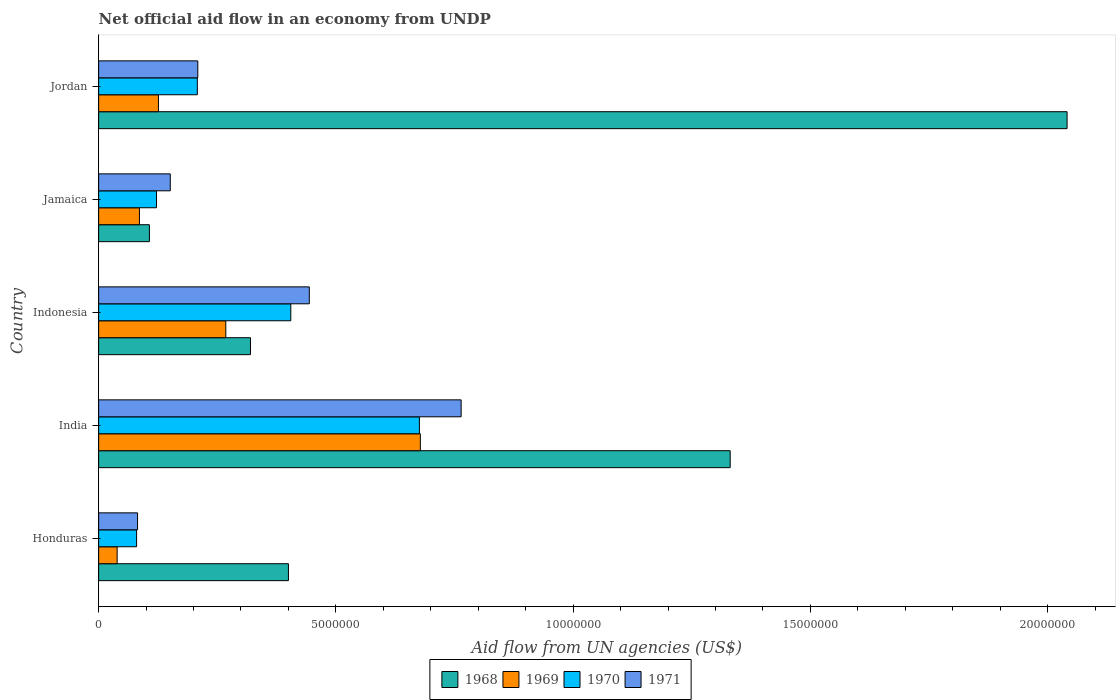How many different coloured bars are there?
Make the answer very short. 4. Are the number of bars per tick equal to the number of legend labels?
Make the answer very short. Yes. How many bars are there on the 3rd tick from the top?
Keep it short and to the point. 4. In how many cases, is the number of bars for a given country not equal to the number of legend labels?
Ensure brevity in your answer.  0. What is the net official aid flow in 1970 in India?
Provide a succinct answer. 6.76e+06. Across all countries, what is the maximum net official aid flow in 1969?
Offer a very short reply. 6.78e+06. Across all countries, what is the minimum net official aid flow in 1968?
Ensure brevity in your answer.  1.07e+06. In which country was the net official aid flow in 1968 maximum?
Provide a short and direct response. Jordan. In which country was the net official aid flow in 1968 minimum?
Offer a terse response. Jamaica. What is the total net official aid flow in 1969 in the graph?
Offer a terse response. 1.20e+07. What is the difference between the net official aid flow in 1968 in Honduras and that in Jordan?
Provide a short and direct response. -1.64e+07. What is the difference between the net official aid flow in 1971 in Jordan and the net official aid flow in 1969 in Indonesia?
Your response must be concise. -5.90e+05. What is the average net official aid flow in 1971 per country?
Your answer should be very brief. 3.30e+06. What is the ratio of the net official aid flow in 1970 in Honduras to that in India?
Provide a succinct answer. 0.12. What is the difference between the highest and the second highest net official aid flow in 1969?
Make the answer very short. 4.10e+06. What is the difference between the highest and the lowest net official aid flow in 1971?
Make the answer very short. 6.82e+06. In how many countries, is the net official aid flow in 1969 greater than the average net official aid flow in 1969 taken over all countries?
Ensure brevity in your answer.  2. Is the sum of the net official aid flow in 1971 in Honduras and Jordan greater than the maximum net official aid flow in 1969 across all countries?
Keep it short and to the point. No. What does the 3rd bar from the top in Jordan represents?
Your response must be concise. 1969. What does the 1st bar from the bottom in India represents?
Keep it short and to the point. 1968. Is it the case that in every country, the sum of the net official aid flow in 1971 and net official aid flow in 1968 is greater than the net official aid flow in 1969?
Your answer should be very brief. Yes. How many bars are there?
Offer a terse response. 20. How many countries are there in the graph?
Offer a terse response. 5. Where does the legend appear in the graph?
Offer a very short reply. Bottom center. How many legend labels are there?
Your answer should be compact. 4. What is the title of the graph?
Your answer should be very brief. Net official aid flow in an economy from UNDP. Does "2008" appear as one of the legend labels in the graph?
Your answer should be very brief. No. What is the label or title of the X-axis?
Provide a succinct answer. Aid flow from UN agencies (US$). What is the label or title of the Y-axis?
Provide a short and direct response. Country. What is the Aid flow from UN agencies (US$) in 1968 in Honduras?
Make the answer very short. 4.00e+06. What is the Aid flow from UN agencies (US$) of 1970 in Honduras?
Ensure brevity in your answer.  8.00e+05. What is the Aid flow from UN agencies (US$) of 1971 in Honduras?
Offer a terse response. 8.20e+05. What is the Aid flow from UN agencies (US$) in 1968 in India?
Give a very brief answer. 1.33e+07. What is the Aid flow from UN agencies (US$) in 1969 in India?
Ensure brevity in your answer.  6.78e+06. What is the Aid flow from UN agencies (US$) in 1970 in India?
Your answer should be compact. 6.76e+06. What is the Aid flow from UN agencies (US$) in 1971 in India?
Your answer should be compact. 7.64e+06. What is the Aid flow from UN agencies (US$) in 1968 in Indonesia?
Offer a very short reply. 3.20e+06. What is the Aid flow from UN agencies (US$) in 1969 in Indonesia?
Your answer should be compact. 2.68e+06. What is the Aid flow from UN agencies (US$) of 1970 in Indonesia?
Make the answer very short. 4.05e+06. What is the Aid flow from UN agencies (US$) of 1971 in Indonesia?
Your response must be concise. 4.44e+06. What is the Aid flow from UN agencies (US$) of 1968 in Jamaica?
Your answer should be compact. 1.07e+06. What is the Aid flow from UN agencies (US$) of 1969 in Jamaica?
Offer a terse response. 8.60e+05. What is the Aid flow from UN agencies (US$) of 1970 in Jamaica?
Give a very brief answer. 1.22e+06. What is the Aid flow from UN agencies (US$) in 1971 in Jamaica?
Offer a very short reply. 1.51e+06. What is the Aid flow from UN agencies (US$) of 1968 in Jordan?
Offer a very short reply. 2.04e+07. What is the Aid flow from UN agencies (US$) of 1969 in Jordan?
Give a very brief answer. 1.26e+06. What is the Aid flow from UN agencies (US$) in 1970 in Jordan?
Offer a very short reply. 2.08e+06. What is the Aid flow from UN agencies (US$) in 1971 in Jordan?
Make the answer very short. 2.09e+06. Across all countries, what is the maximum Aid flow from UN agencies (US$) in 1968?
Make the answer very short. 2.04e+07. Across all countries, what is the maximum Aid flow from UN agencies (US$) of 1969?
Your answer should be compact. 6.78e+06. Across all countries, what is the maximum Aid flow from UN agencies (US$) of 1970?
Your answer should be very brief. 6.76e+06. Across all countries, what is the maximum Aid flow from UN agencies (US$) in 1971?
Your answer should be very brief. 7.64e+06. Across all countries, what is the minimum Aid flow from UN agencies (US$) in 1968?
Offer a very short reply. 1.07e+06. Across all countries, what is the minimum Aid flow from UN agencies (US$) in 1970?
Ensure brevity in your answer.  8.00e+05. Across all countries, what is the minimum Aid flow from UN agencies (US$) in 1971?
Your response must be concise. 8.20e+05. What is the total Aid flow from UN agencies (US$) in 1968 in the graph?
Provide a short and direct response. 4.20e+07. What is the total Aid flow from UN agencies (US$) of 1969 in the graph?
Offer a very short reply. 1.20e+07. What is the total Aid flow from UN agencies (US$) in 1970 in the graph?
Make the answer very short. 1.49e+07. What is the total Aid flow from UN agencies (US$) in 1971 in the graph?
Keep it short and to the point. 1.65e+07. What is the difference between the Aid flow from UN agencies (US$) in 1968 in Honduras and that in India?
Your answer should be compact. -9.31e+06. What is the difference between the Aid flow from UN agencies (US$) of 1969 in Honduras and that in India?
Offer a terse response. -6.39e+06. What is the difference between the Aid flow from UN agencies (US$) of 1970 in Honduras and that in India?
Ensure brevity in your answer.  -5.96e+06. What is the difference between the Aid flow from UN agencies (US$) in 1971 in Honduras and that in India?
Ensure brevity in your answer.  -6.82e+06. What is the difference between the Aid flow from UN agencies (US$) in 1969 in Honduras and that in Indonesia?
Give a very brief answer. -2.29e+06. What is the difference between the Aid flow from UN agencies (US$) of 1970 in Honduras and that in Indonesia?
Provide a short and direct response. -3.25e+06. What is the difference between the Aid flow from UN agencies (US$) of 1971 in Honduras and that in Indonesia?
Your response must be concise. -3.62e+06. What is the difference between the Aid flow from UN agencies (US$) of 1968 in Honduras and that in Jamaica?
Give a very brief answer. 2.93e+06. What is the difference between the Aid flow from UN agencies (US$) of 1969 in Honduras and that in Jamaica?
Provide a short and direct response. -4.70e+05. What is the difference between the Aid flow from UN agencies (US$) in 1970 in Honduras and that in Jamaica?
Make the answer very short. -4.20e+05. What is the difference between the Aid flow from UN agencies (US$) of 1971 in Honduras and that in Jamaica?
Your answer should be very brief. -6.90e+05. What is the difference between the Aid flow from UN agencies (US$) of 1968 in Honduras and that in Jordan?
Your response must be concise. -1.64e+07. What is the difference between the Aid flow from UN agencies (US$) of 1969 in Honduras and that in Jordan?
Keep it short and to the point. -8.70e+05. What is the difference between the Aid flow from UN agencies (US$) in 1970 in Honduras and that in Jordan?
Offer a terse response. -1.28e+06. What is the difference between the Aid flow from UN agencies (US$) in 1971 in Honduras and that in Jordan?
Provide a short and direct response. -1.27e+06. What is the difference between the Aid flow from UN agencies (US$) of 1968 in India and that in Indonesia?
Keep it short and to the point. 1.01e+07. What is the difference between the Aid flow from UN agencies (US$) in 1969 in India and that in Indonesia?
Make the answer very short. 4.10e+06. What is the difference between the Aid flow from UN agencies (US$) in 1970 in India and that in Indonesia?
Your response must be concise. 2.71e+06. What is the difference between the Aid flow from UN agencies (US$) of 1971 in India and that in Indonesia?
Keep it short and to the point. 3.20e+06. What is the difference between the Aid flow from UN agencies (US$) of 1968 in India and that in Jamaica?
Keep it short and to the point. 1.22e+07. What is the difference between the Aid flow from UN agencies (US$) in 1969 in India and that in Jamaica?
Keep it short and to the point. 5.92e+06. What is the difference between the Aid flow from UN agencies (US$) of 1970 in India and that in Jamaica?
Your answer should be very brief. 5.54e+06. What is the difference between the Aid flow from UN agencies (US$) of 1971 in India and that in Jamaica?
Offer a very short reply. 6.13e+06. What is the difference between the Aid flow from UN agencies (US$) of 1968 in India and that in Jordan?
Your answer should be compact. -7.10e+06. What is the difference between the Aid flow from UN agencies (US$) in 1969 in India and that in Jordan?
Give a very brief answer. 5.52e+06. What is the difference between the Aid flow from UN agencies (US$) of 1970 in India and that in Jordan?
Your response must be concise. 4.68e+06. What is the difference between the Aid flow from UN agencies (US$) in 1971 in India and that in Jordan?
Keep it short and to the point. 5.55e+06. What is the difference between the Aid flow from UN agencies (US$) of 1968 in Indonesia and that in Jamaica?
Your response must be concise. 2.13e+06. What is the difference between the Aid flow from UN agencies (US$) in 1969 in Indonesia and that in Jamaica?
Your answer should be compact. 1.82e+06. What is the difference between the Aid flow from UN agencies (US$) in 1970 in Indonesia and that in Jamaica?
Offer a terse response. 2.83e+06. What is the difference between the Aid flow from UN agencies (US$) in 1971 in Indonesia and that in Jamaica?
Give a very brief answer. 2.93e+06. What is the difference between the Aid flow from UN agencies (US$) in 1968 in Indonesia and that in Jordan?
Offer a terse response. -1.72e+07. What is the difference between the Aid flow from UN agencies (US$) in 1969 in Indonesia and that in Jordan?
Ensure brevity in your answer.  1.42e+06. What is the difference between the Aid flow from UN agencies (US$) of 1970 in Indonesia and that in Jordan?
Offer a very short reply. 1.97e+06. What is the difference between the Aid flow from UN agencies (US$) in 1971 in Indonesia and that in Jordan?
Offer a very short reply. 2.35e+06. What is the difference between the Aid flow from UN agencies (US$) in 1968 in Jamaica and that in Jordan?
Your answer should be compact. -1.93e+07. What is the difference between the Aid flow from UN agencies (US$) of 1969 in Jamaica and that in Jordan?
Offer a very short reply. -4.00e+05. What is the difference between the Aid flow from UN agencies (US$) in 1970 in Jamaica and that in Jordan?
Provide a short and direct response. -8.60e+05. What is the difference between the Aid flow from UN agencies (US$) in 1971 in Jamaica and that in Jordan?
Your answer should be very brief. -5.80e+05. What is the difference between the Aid flow from UN agencies (US$) in 1968 in Honduras and the Aid flow from UN agencies (US$) in 1969 in India?
Ensure brevity in your answer.  -2.78e+06. What is the difference between the Aid flow from UN agencies (US$) in 1968 in Honduras and the Aid flow from UN agencies (US$) in 1970 in India?
Keep it short and to the point. -2.76e+06. What is the difference between the Aid flow from UN agencies (US$) of 1968 in Honduras and the Aid flow from UN agencies (US$) of 1971 in India?
Provide a succinct answer. -3.64e+06. What is the difference between the Aid flow from UN agencies (US$) of 1969 in Honduras and the Aid flow from UN agencies (US$) of 1970 in India?
Provide a succinct answer. -6.37e+06. What is the difference between the Aid flow from UN agencies (US$) of 1969 in Honduras and the Aid flow from UN agencies (US$) of 1971 in India?
Your answer should be compact. -7.25e+06. What is the difference between the Aid flow from UN agencies (US$) in 1970 in Honduras and the Aid flow from UN agencies (US$) in 1971 in India?
Keep it short and to the point. -6.84e+06. What is the difference between the Aid flow from UN agencies (US$) in 1968 in Honduras and the Aid flow from UN agencies (US$) in 1969 in Indonesia?
Offer a terse response. 1.32e+06. What is the difference between the Aid flow from UN agencies (US$) of 1968 in Honduras and the Aid flow from UN agencies (US$) of 1971 in Indonesia?
Provide a short and direct response. -4.40e+05. What is the difference between the Aid flow from UN agencies (US$) of 1969 in Honduras and the Aid flow from UN agencies (US$) of 1970 in Indonesia?
Your answer should be compact. -3.66e+06. What is the difference between the Aid flow from UN agencies (US$) in 1969 in Honduras and the Aid flow from UN agencies (US$) in 1971 in Indonesia?
Your answer should be very brief. -4.05e+06. What is the difference between the Aid flow from UN agencies (US$) in 1970 in Honduras and the Aid flow from UN agencies (US$) in 1971 in Indonesia?
Your answer should be compact. -3.64e+06. What is the difference between the Aid flow from UN agencies (US$) of 1968 in Honduras and the Aid flow from UN agencies (US$) of 1969 in Jamaica?
Ensure brevity in your answer.  3.14e+06. What is the difference between the Aid flow from UN agencies (US$) of 1968 in Honduras and the Aid flow from UN agencies (US$) of 1970 in Jamaica?
Offer a very short reply. 2.78e+06. What is the difference between the Aid flow from UN agencies (US$) in 1968 in Honduras and the Aid flow from UN agencies (US$) in 1971 in Jamaica?
Offer a very short reply. 2.49e+06. What is the difference between the Aid flow from UN agencies (US$) in 1969 in Honduras and the Aid flow from UN agencies (US$) in 1970 in Jamaica?
Your response must be concise. -8.30e+05. What is the difference between the Aid flow from UN agencies (US$) in 1969 in Honduras and the Aid flow from UN agencies (US$) in 1971 in Jamaica?
Offer a terse response. -1.12e+06. What is the difference between the Aid flow from UN agencies (US$) of 1970 in Honduras and the Aid flow from UN agencies (US$) of 1971 in Jamaica?
Offer a very short reply. -7.10e+05. What is the difference between the Aid flow from UN agencies (US$) in 1968 in Honduras and the Aid flow from UN agencies (US$) in 1969 in Jordan?
Give a very brief answer. 2.74e+06. What is the difference between the Aid flow from UN agencies (US$) in 1968 in Honduras and the Aid flow from UN agencies (US$) in 1970 in Jordan?
Provide a short and direct response. 1.92e+06. What is the difference between the Aid flow from UN agencies (US$) in 1968 in Honduras and the Aid flow from UN agencies (US$) in 1971 in Jordan?
Give a very brief answer. 1.91e+06. What is the difference between the Aid flow from UN agencies (US$) of 1969 in Honduras and the Aid flow from UN agencies (US$) of 1970 in Jordan?
Give a very brief answer. -1.69e+06. What is the difference between the Aid flow from UN agencies (US$) of 1969 in Honduras and the Aid flow from UN agencies (US$) of 1971 in Jordan?
Offer a very short reply. -1.70e+06. What is the difference between the Aid flow from UN agencies (US$) of 1970 in Honduras and the Aid flow from UN agencies (US$) of 1971 in Jordan?
Your answer should be compact. -1.29e+06. What is the difference between the Aid flow from UN agencies (US$) of 1968 in India and the Aid flow from UN agencies (US$) of 1969 in Indonesia?
Offer a terse response. 1.06e+07. What is the difference between the Aid flow from UN agencies (US$) in 1968 in India and the Aid flow from UN agencies (US$) in 1970 in Indonesia?
Offer a terse response. 9.26e+06. What is the difference between the Aid flow from UN agencies (US$) of 1968 in India and the Aid flow from UN agencies (US$) of 1971 in Indonesia?
Your answer should be very brief. 8.87e+06. What is the difference between the Aid flow from UN agencies (US$) of 1969 in India and the Aid flow from UN agencies (US$) of 1970 in Indonesia?
Provide a succinct answer. 2.73e+06. What is the difference between the Aid flow from UN agencies (US$) in 1969 in India and the Aid flow from UN agencies (US$) in 1971 in Indonesia?
Your response must be concise. 2.34e+06. What is the difference between the Aid flow from UN agencies (US$) in 1970 in India and the Aid flow from UN agencies (US$) in 1971 in Indonesia?
Make the answer very short. 2.32e+06. What is the difference between the Aid flow from UN agencies (US$) of 1968 in India and the Aid flow from UN agencies (US$) of 1969 in Jamaica?
Give a very brief answer. 1.24e+07. What is the difference between the Aid flow from UN agencies (US$) of 1968 in India and the Aid flow from UN agencies (US$) of 1970 in Jamaica?
Provide a short and direct response. 1.21e+07. What is the difference between the Aid flow from UN agencies (US$) of 1968 in India and the Aid flow from UN agencies (US$) of 1971 in Jamaica?
Offer a terse response. 1.18e+07. What is the difference between the Aid flow from UN agencies (US$) in 1969 in India and the Aid flow from UN agencies (US$) in 1970 in Jamaica?
Your response must be concise. 5.56e+06. What is the difference between the Aid flow from UN agencies (US$) in 1969 in India and the Aid flow from UN agencies (US$) in 1971 in Jamaica?
Your answer should be compact. 5.27e+06. What is the difference between the Aid flow from UN agencies (US$) in 1970 in India and the Aid flow from UN agencies (US$) in 1971 in Jamaica?
Offer a terse response. 5.25e+06. What is the difference between the Aid flow from UN agencies (US$) in 1968 in India and the Aid flow from UN agencies (US$) in 1969 in Jordan?
Provide a succinct answer. 1.20e+07. What is the difference between the Aid flow from UN agencies (US$) of 1968 in India and the Aid flow from UN agencies (US$) of 1970 in Jordan?
Your answer should be compact. 1.12e+07. What is the difference between the Aid flow from UN agencies (US$) in 1968 in India and the Aid flow from UN agencies (US$) in 1971 in Jordan?
Offer a terse response. 1.12e+07. What is the difference between the Aid flow from UN agencies (US$) of 1969 in India and the Aid flow from UN agencies (US$) of 1970 in Jordan?
Keep it short and to the point. 4.70e+06. What is the difference between the Aid flow from UN agencies (US$) in 1969 in India and the Aid flow from UN agencies (US$) in 1971 in Jordan?
Offer a terse response. 4.69e+06. What is the difference between the Aid flow from UN agencies (US$) of 1970 in India and the Aid flow from UN agencies (US$) of 1971 in Jordan?
Keep it short and to the point. 4.67e+06. What is the difference between the Aid flow from UN agencies (US$) in 1968 in Indonesia and the Aid flow from UN agencies (US$) in 1969 in Jamaica?
Your response must be concise. 2.34e+06. What is the difference between the Aid flow from UN agencies (US$) of 1968 in Indonesia and the Aid flow from UN agencies (US$) of 1970 in Jamaica?
Offer a very short reply. 1.98e+06. What is the difference between the Aid flow from UN agencies (US$) in 1968 in Indonesia and the Aid flow from UN agencies (US$) in 1971 in Jamaica?
Offer a terse response. 1.69e+06. What is the difference between the Aid flow from UN agencies (US$) of 1969 in Indonesia and the Aid flow from UN agencies (US$) of 1970 in Jamaica?
Make the answer very short. 1.46e+06. What is the difference between the Aid flow from UN agencies (US$) of 1969 in Indonesia and the Aid flow from UN agencies (US$) of 1971 in Jamaica?
Your answer should be compact. 1.17e+06. What is the difference between the Aid flow from UN agencies (US$) in 1970 in Indonesia and the Aid flow from UN agencies (US$) in 1971 in Jamaica?
Offer a terse response. 2.54e+06. What is the difference between the Aid flow from UN agencies (US$) of 1968 in Indonesia and the Aid flow from UN agencies (US$) of 1969 in Jordan?
Your response must be concise. 1.94e+06. What is the difference between the Aid flow from UN agencies (US$) of 1968 in Indonesia and the Aid flow from UN agencies (US$) of 1970 in Jordan?
Offer a very short reply. 1.12e+06. What is the difference between the Aid flow from UN agencies (US$) of 1968 in Indonesia and the Aid flow from UN agencies (US$) of 1971 in Jordan?
Your answer should be compact. 1.11e+06. What is the difference between the Aid flow from UN agencies (US$) of 1969 in Indonesia and the Aid flow from UN agencies (US$) of 1971 in Jordan?
Offer a terse response. 5.90e+05. What is the difference between the Aid flow from UN agencies (US$) in 1970 in Indonesia and the Aid flow from UN agencies (US$) in 1971 in Jordan?
Make the answer very short. 1.96e+06. What is the difference between the Aid flow from UN agencies (US$) in 1968 in Jamaica and the Aid flow from UN agencies (US$) in 1969 in Jordan?
Your answer should be very brief. -1.90e+05. What is the difference between the Aid flow from UN agencies (US$) in 1968 in Jamaica and the Aid flow from UN agencies (US$) in 1970 in Jordan?
Ensure brevity in your answer.  -1.01e+06. What is the difference between the Aid flow from UN agencies (US$) of 1968 in Jamaica and the Aid flow from UN agencies (US$) of 1971 in Jordan?
Make the answer very short. -1.02e+06. What is the difference between the Aid flow from UN agencies (US$) in 1969 in Jamaica and the Aid flow from UN agencies (US$) in 1970 in Jordan?
Your response must be concise. -1.22e+06. What is the difference between the Aid flow from UN agencies (US$) of 1969 in Jamaica and the Aid flow from UN agencies (US$) of 1971 in Jordan?
Provide a succinct answer. -1.23e+06. What is the difference between the Aid flow from UN agencies (US$) of 1970 in Jamaica and the Aid flow from UN agencies (US$) of 1971 in Jordan?
Ensure brevity in your answer.  -8.70e+05. What is the average Aid flow from UN agencies (US$) of 1968 per country?
Your answer should be very brief. 8.40e+06. What is the average Aid flow from UN agencies (US$) in 1969 per country?
Provide a short and direct response. 2.39e+06. What is the average Aid flow from UN agencies (US$) of 1970 per country?
Your answer should be compact. 2.98e+06. What is the average Aid flow from UN agencies (US$) in 1971 per country?
Make the answer very short. 3.30e+06. What is the difference between the Aid flow from UN agencies (US$) in 1968 and Aid flow from UN agencies (US$) in 1969 in Honduras?
Keep it short and to the point. 3.61e+06. What is the difference between the Aid flow from UN agencies (US$) in 1968 and Aid flow from UN agencies (US$) in 1970 in Honduras?
Offer a very short reply. 3.20e+06. What is the difference between the Aid flow from UN agencies (US$) of 1968 and Aid flow from UN agencies (US$) of 1971 in Honduras?
Keep it short and to the point. 3.18e+06. What is the difference between the Aid flow from UN agencies (US$) of 1969 and Aid flow from UN agencies (US$) of 1970 in Honduras?
Ensure brevity in your answer.  -4.10e+05. What is the difference between the Aid flow from UN agencies (US$) of 1969 and Aid flow from UN agencies (US$) of 1971 in Honduras?
Provide a short and direct response. -4.30e+05. What is the difference between the Aid flow from UN agencies (US$) of 1970 and Aid flow from UN agencies (US$) of 1971 in Honduras?
Provide a succinct answer. -2.00e+04. What is the difference between the Aid flow from UN agencies (US$) in 1968 and Aid flow from UN agencies (US$) in 1969 in India?
Make the answer very short. 6.53e+06. What is the difference between the Aid flow from UN agencies (US$) in 1968 and Aid flow from UN agencies (US$) in 1970 in India?
Provide a short and direct response. 6.55e+06. What is the difference between the Aid flow from UN agencies (US$) in 1968 and Aid flow from UN agencies (US$) in 1971 in India?
Your answer should be very brief. 5.67e+06. What is the difference between the Aid flow from UN agencies (US$) of 1969 and Aid flow from UN agencies (US$) of 1971 in India?
Give a very brief answer. -8.60e+05. What is the difference between the Aid flow from UN agencies (US$) in 1970 and Aid flow from UN agencies (US$) in 1971 in India?
Your response must be concise. -8.80e+05. What is the difference between the Aid flow from UN agencies (US$) of 1968 and Aid flow from UN agencies (US$) of 1969 in Indonesia?
Give a very brief answer. 5.20e+05. What is the difference between the Aid flow from UN agencies (US$) of 1968 and Aid flow from UN agencies (US$) of 1970 in Indonesia?
Keep it short and to the point. -8.50e+05. What is the difference between the Aid flow from UN agencies (US$) in 1968 and Aid flow from UN agencies (US$) in 1971 in Indonesia?
Your answer should be very brief. -1.24e+06. What is the difference between the Aid flow from UN agencies (US$) of 1969 and Aid flow from UN agencies (US$) of 1970 in Indonesia?
Offer a terse response. -1.37e+06. What is the difference between the Aid flow from UN agencies (US$) of 1969 and Aid flow from UN agencies (US$) of 1971 in Indonesia?
Give a very brief answer. -1.76e+06. What is the difference between the Aid flow from UN agencies (US$) of 1970 and Aid flow from UN agencies (US$) of 1971 in Indonesia?
Provide a succinct answer. -3.90e+05. What is the difference between the Aid flow from UN agencies (US$) of 1968 and Aid flow from UN agencies (US$) of 1969 in Jamaica?
Make the answer very short. 2.10e+05. What is the difference between the Aid flow from UN agencies (US$) in 1968 and Aid flow from UN agencies (US$) in 1971 in Jamaica?
Offer a terse response. -4.40e+05. What is the difference between the Aid flow from UN agencies (US$) of 1969 and Aid flow from UN agencies (US$) of 1970 in Jamaica?
Your answer should be compact. -3.60e+05. What is the difference between the Aid flow from UN agencies (US$) in 1969 and Aid flow from UN agencies (US$) in 1971 in Jamaica?
Make the answer very short. -6.50e+05. What is the difference between the Aid flow from UN agencies (US$) in 1968 and Aid flow from UN agencies (US$) in 1969 in Jordan?
Provide a succinct answer. 1.92e+07. What is the difference between the Aid flow from UN agencies (US$) in 1968 and Aid flow from UN agencies (US$) in 1970 in Jordan?
Give a very brief answer. 1.83e+07. What is the difference between the Aid flow from UN agencies (US$) of 1968 and Aid flow from UN agencies (US$) of 1971 in Jordan?
Make the answer very short. 1.83e+07. What is the difference between the Aid flow from UN agencies (US$) in 1969 and Aid flow from UN agencies (US$) in 1970 in Jordan?
Make the answer very short. -8.20e+05. What is the difference between the Aid flow from UN agencies (US$) of 1969 and Aid flow from UN agencies (US$) of 1971 in Jordan?
Offer a very short reply. -8.30e+05. What is the ratio of the Aid flow from UN agencies (US$) of 1968 in Honduras to that in India?
Provide a short and direct response. 0.3. What is the ratio of the Aid flow from UN agencies (US$) in 1969 in Honduras to that in India?
Your response must be concise. 0.06. What is the ratio of the Aid flow from UN agencies (US$) of 1970 in Honduras to that in India?
Provide a succinct answer. 0.12. What is the ratio of the Aid flow from UN agencies (US$) of 1971 in Honduras to that in India?
Give a very brief answer. 0.11. What is the ratio of the Aid flow from UN agencies (US$) in 1969 in Honduras to that in Indonesia?
Offer a very short reply. 0.15. What is the ratio of the Aid flow from UN agencies (US$) of 1970 in Honduras to that in Indonesia?
Provide a succinct answer. 0.2. What is the ratio of the Aid flow from UN agencies (US$) in 1971 in Honduras to that in Indonesia?
Give a very brief answer. 0.18. What is the ratio of the Aid flow from UN agencies (US$) of 1968 in Honduras to that in Jamaica?
Offer a very short reply. 3.74. What is the ratio of the Aid flow from UN agencies (US$) of 1969 in Honduras to that in Jamaica?
Give a very brief answer. 0.45. What is the ratio of the Aid flow from UN agencies (US$) in 1970 in Honduras to that in Jamaica?
Provide a short and direct response. 0.66. What is the ratio of the Aid flow from UN agencies (US$) of 1971 in Honduras to that in Jamaica?
Your response must be concise. 0.54. What is the ratio of the Aid flow from UN agencies (US$) of 1968 in Honduras to that in Jordan?
Offer a terse response. 0.2. What is the ratio of the Aid flow from UN agencies (US$) of 1969 in Honduras to that in Jordan?
Offer a very short reply. 0.31. What is the ratio of the Aid flow from UN agencies (US$) of 1970 in Honduras to that in Jordan?
Your answer should be compact. 0.38. What is the ratio of the Aid flow from UN agencies (US$) of 1971 in Honduras to that in Jordan?
Ensure brevity in your answer.  0.39. What is the ratio of the Aid flow from UN agencies (US$) in 1968 in India to that in Indonesia?
Offer a terse response. 4.16. What is the ratio of the Aid flow from UN agencies (US$) in 1969 in India to that in Indonesia?
Ensure brevity in your answer.  2.53. What is the ratio of the Aid flow from UN agencies (US$) in 1970 in India to that in Indonesia?
Make the answer very short. 1.67. What is the ratio of the Aid flow from UN agencies (US$) of 1971 in India to that in Indonesia?
Provide a succinct answer. 1.72. What is the ratio of the Aid flow from UN agencies (US$) in 1968 in India to that in Jamaica?
Keep it short and to the point. 12.44. What is the ratio of the Aid flow from UN agencies (US$) in 1969 in India to that in Jamaica?
Make the answer very short. 7.88. What is the ratio of the Aid flow from UN agencies (US$) of 1970 in India to that in Jamaica?
Offer a terse response. 5.54. What is the ratio of the Aid flow from UN agencies (US$) in 1971 in India to that in Jamaica?
Offer a very short reply. 5.06. What is the ratio of the Aid flow from UN agencies (US$) of 1968 in India to that in Jordan?
Your answer should be compact. 0.65. What is the ratio of the Aid flow from UN agencies (US$) in 1969 in India to that in Jordan?
Your response must be concise. 5.38. What is the ratio of the Aid flow from UN agencies (US$) of 1971 in India to that in Jordan?
Provide a succinct answer. 3.66. What is the ratio of the Aid flow from UN agencies (US$) in 1968 in Indonesia to that in Jamaica?
Give a very brief answer. 2.99. What is the ratio of the Aid flow from UN agencies (US$) of 1969 in Indonesia to that in Jamaica?
Give a very brief answer. 3.12. What is the ratio of the Aid flow from UN agencies (US$) in 1970 in Indonesia to that in Jamaica?
Keep it short and to the point. 3.32. What is the ratio of the Aid flow from UN agencies (US$) in 1971 in Indonesia to that in Jamaica?
Provide a short and direct response. 2.94. What is the ratio of the Aid flow from UN agencies (US$) of 1968 in Indonesia to that in Jordan?
Make the answer very short. 0.16. What is the ratio of the Aid flow from UN agencies (US$) of 1969 in Indonesia to that in Jordan?
Provide a succinct answer. 2.13. What is the ratio of the Aid flow from UN agencies (US$) of 1970 in Indonesia to that in Jordan?
Ensure brevity in your answer.  1.95. What is the ratio of the Aid flow from UN agencies (US$) in 1971 in Indonesia to that in Jordan?
Offer a terse response. 2.12. What is the ratio of the Aid flow from UN agencies (US$) in 1968 in Jamaica to that in Jordan?
Keep it short and to the point. 0.05. What is the ratio of the Aid flow from UN agencies (US$) in 1969 in Jamaica to that in Jordan?
Offer a terse response. 0.68. What is the ratio of the Aid flow from UN agencies (US$) of 1970 in Jamaica to that in Jordan?
Your answer should be very brief. 0.59. What is the ratio of the Aid flow from UN agencies (US$) of 1971 in Jamaica to that in Jordan?
Keep it short and to the point. 0.72. What is the difference between the highest and the second highest Aid flow from UN agencies (US$) in 1968?
Make the answer very short. 7.10e+06. What is the difference between the highest and the second highest Aid flow from UN agencies (US$) in 1969?
Ensure brevity in your answer.  4.10e+06. What is the difference between the highest and the second highest Aid flow from UN agencies (US$) of 1970?
Your answer should be very brief. 2.71e+06. What is the difference between the highest and the second highest Aid flow from UN agencies (US$) in 1971?
Provide a short and direct response. 3.20e+06. What is the difference between the highest and the lowest Aid flow from UN agencies (US$) of 1968?
Ensure brevity in your answer.  1.93e+07. What is the difference between the highest and the lowest Aid flow from UN agencies (US$) of 1969?
Make the answer very short. 6.39e+06. What is the difference between the highest and the lowest Aid flow from UN agencies (US$) of 1970?
Provide a short and direct response. 5.96e+06. What is the difference between the highest and the lowest Aid flow from UN agencies (US$) of 1971?
Provide a short and direct response. 6.82e+06. 